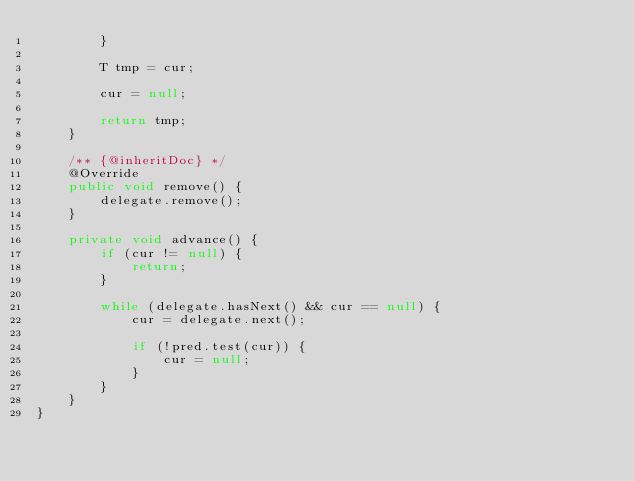Convert code to text. <code><loc_0><loc_0><loc_500><loc_500><_Java_>        }

        T tmp = cur;

        cur = null;

        return tmp;
    }

    /** {@inheritDoc} */
    @Override
    public void remove() {
        delegate.remove();
    }

    private void advance() {
        if (cur != null) {
            return;
        }

        while (delegate.hasNext() && cur == null) {
            cur = delegate.next();

            if (!pred.test(cur)) {
                cur = null;
            }
        }
    }
}
</code> 